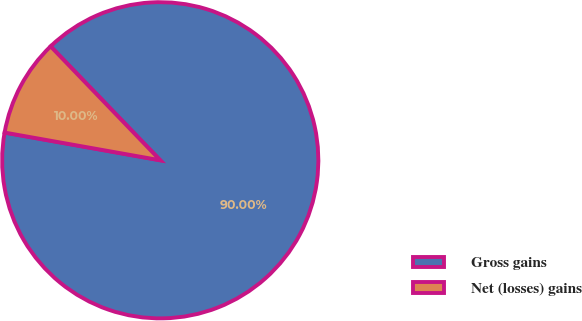Convert chart. <chart><loc_0><loc_0><loc_500><loc_500><pie_chart><fcel>Gross gains<fcel>Net (losses) gains<nl><fcel>90.0%<fcel>10.0%<nl></chart> 